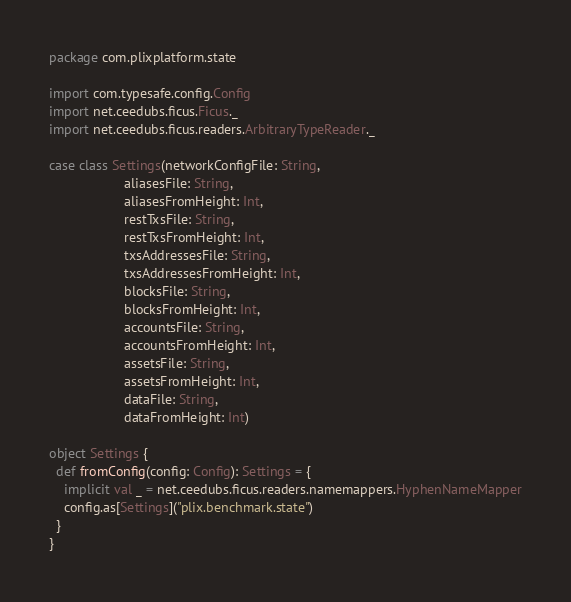<code> <loc_0><loc_0><loc_500><loc_500><_Scala_>package com.plixplatform.state

import com.typesafe.config.Config
import net.ceedubs.ficus.Ficus._
import net.ceedubs.ficus.readers.ArbitraryTypeReader._

case class Settings(networkConfigFile: String,
                    aliasesFile: String,
                    aliasesFromHeight: Int,
                    restTxsFile: String,
                    restTxsFromHeight: Int,
                    txsAddressesFile: String,
                    txsAddressesFromHeight: Int,
                    blocksFile: String,
                    blocksFromHeight: Int,
                    accountsFile: String,
                    accountsFromHeight: Int,
                    assetsFile: String,
                    assetsFromHeight: Int,
                    dataFile: String,
                    dataFromHeight: Int)

object Settings {
  def fromConfig(config: Config): Settings = {
    implicit val _ = net.ceedubs.ficus.readers.namemappers.HyphenNameMapper
    config.as[Settings]("plix.benchmark.state")
  }
}
</code> 